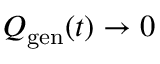<formula> <loc_0><loc_0><loc_500><loc_500>Q _ { g e n } ( t ) \rightarrow 0</formula> 